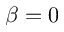Convert formula to latex. <formula><loc_0><loc_0><loc_500><loc_500>\beta = 0</formula> 